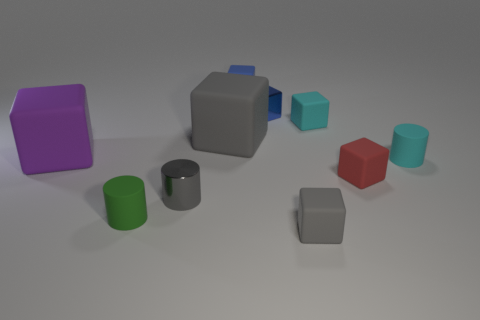Subtract all yellow spheres. How many blue cubes are left? 2 Subtract all blue rubber blocks. How many blocks are left? 6 Subtract all blue blocks. How many blocks are left? 5 Subtract all purple cylinders. Subtract all purple spheres. How many cylinders are left? 3 Subtract all cubes. How many objects are left? 3 Add 5 blue metal things. How many blue metal things are left? 6 Add 2 cyan rubber cylinders. How many cyan rubber cylinders exist? 3 Subtract 0 green balls. How many objects are left? 10 Subtract all green cubes. Subtract all cyan matte cylinders. How many objects are left? 9 